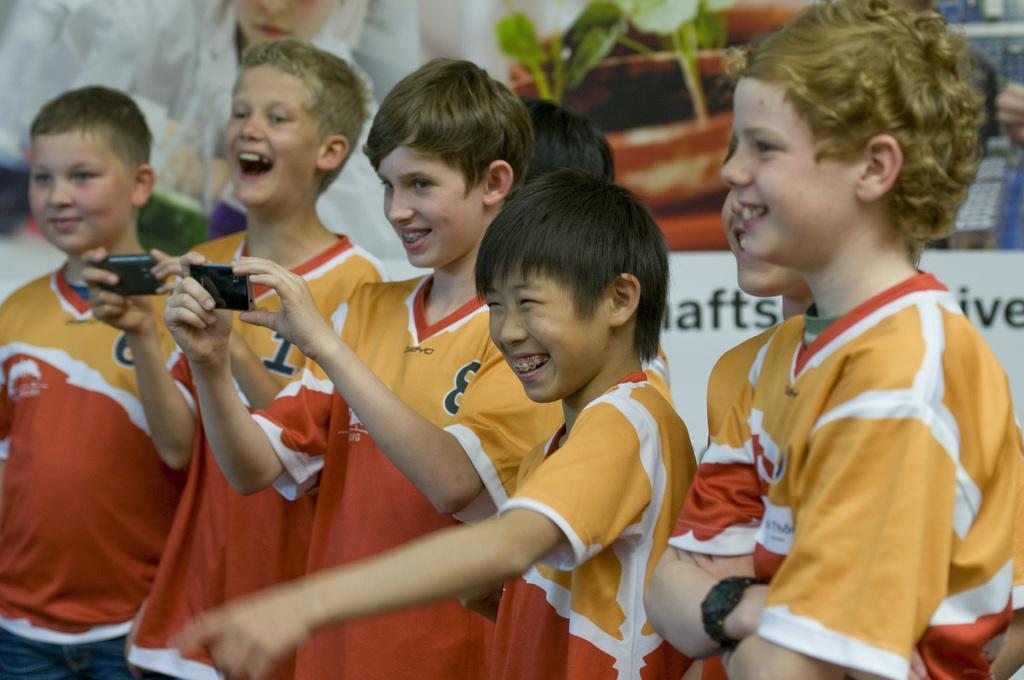<image>
Provide a brief description of the given image. A group of children are wearing matching orange shirts and a sign is behind them that says shafts. 